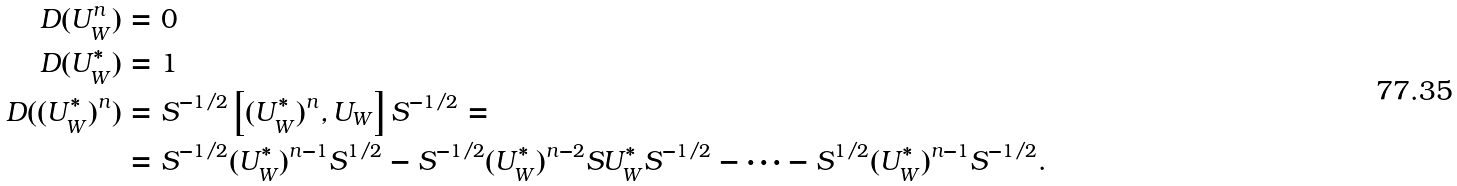<formula> <loc_0><loc_0><loc_500><loc_500>D ( U _ { W } ^ { n } ) & = 0 \\ D ( U _ { W } ^ { * } ) & = 1 \\ D ( ( U _ { W } ^ { * } ) ^ { n } ) & = S ^ { - 1 / 2 } \left [ ( U _ { W } ^ { * } ) ^ { n } , U _ { W } \right ] S ^ { - 1 / 2 } = \\ & = S ^ { - 1 / 2 } ( U _ { W } ^ { * } ) ^ { n - 1 } S ^ { 1 / 2 } - S ^ { - 1 / 2 } ( U _ { W } ^ { * } ) ^ { n - 2 } S U _ { W } ^ { * } S ^ { - 1 / 2 } - \cdots - S ^ { 1 / 2 } ( U _ { W } ^ { * } ) ^ { n - 1 } S ^ { - 1 / 2 } .</formula> 